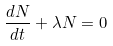<formula> <loc_0><loc_0><loc_500><loc_500>\frac { d N } { d t } + \lambda N = 0</formula> 